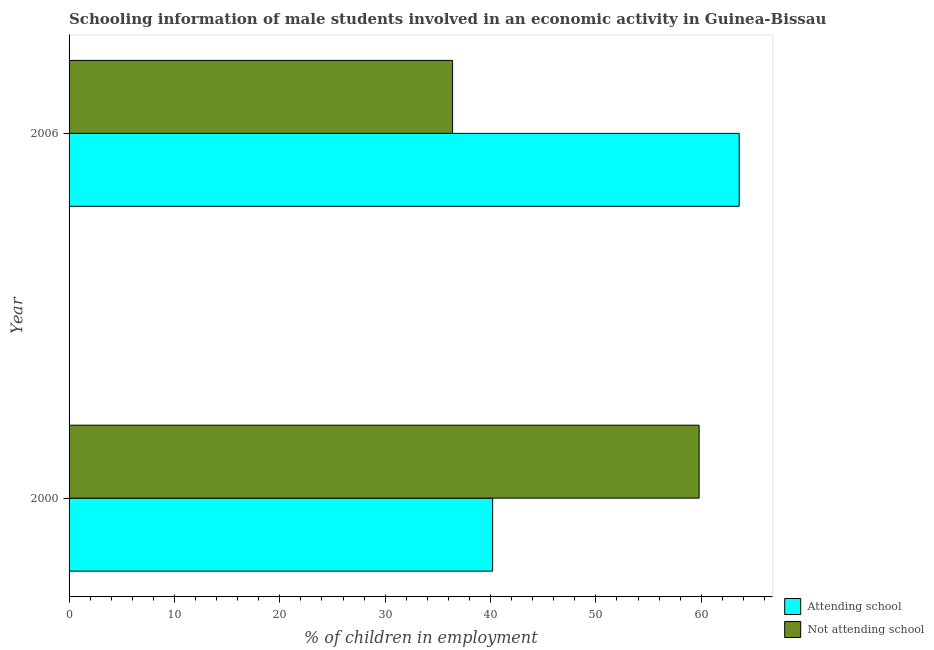How many different coloured bars are there?
Keep it short and to the point. 2. Are the number of bars per tick equal to the number of legend labels?
Ensure brevity in your answer.  Yes. What is the label of the 2nd group of bars from the top?
Offer a very short reply. 2000. What is the percentage of employed males who are not attending school in 2000?
Your response must be concise. 59.8. Across all years, what is the maximum percentage of employed males who are attending school?
Ensure brevity in your answer.  63.6. Across all years, what is the minimum percentage of employed males who are not attending school?
Keep it short and to the point. 36.4. In which year was the percentage of employed males who are not attending school maximum?
Your response must be concise. 2000. What is the total percentage of employed males who are not attending school in the graph?
Keep it short and to the point. 96.2. What is the difference between the percentage of employed males who are attending school in 2000 and that in 2006?
Keep it short and to the point. -23.4. What is the difference between the percentage of employed males who are not attending school in 2000 and the percentage of employed males who are attending school in 2006?
Your answer should be compact. -3.8. What is the average percentage of employed males who are not attending school per year?
Make the answer very short. 48.1. In the year 2006, what is the difference between the percentage of employed males who are attending school and percentage of employed males who are not attending school?
Make the answer very short. 27.2. What is the ratio of the percentage of employed males who are not attending school in 2000 to that in 2006?
Offer a very short reply. 1.64. What does the 1st bar from the top in 2006 represents?
Your answer should be compact. Not attending school. What does the 2nd bar from the bottom in 2006 represents?
Provide a short and direct response. Not attending school. Are all the bars in the graph horizontal?
Offer a very short reply. Yes. What is the difference between two consecutive major ticks on the X-axis?
Offer a very short reply. 10. Are the values on the major ticks of X-axis written in scientific E-notation?
Make the answer very short. No. Does the graph contain grids?
Your answer should be very brief. No. Where does the legend appear in the graph?
Your answer should be very brief. Bottom right. What is the title of the graph?
Your answer should be compact. Schooling information of male students involved in an economic activity in Guinea-Bissau. What is the label or title of the X-axis?
Offer a very short reply. % of children in employment. What is the % of children in employment of Attending school in 2000?
Make the answer very short. 40.2. What is the % of children in employment of Not attending school in 2000?
Provide a succinct answer. 59.8. What is the % of children in employment of Attending school in 2006?
Provide a succinct answer. 63.6. What is the % of children in employment of Not attending school in 2006?
Offer a very short reply. 36.4. Across all years, what is the maximum % of children in employment in Attending school?
Your response must be concise. 63.6. Across all years, what is the maximum % of children in employment of Not attending school?
Ensure brevity in your answer.  59.8. Across all years, what is the minimum % of children in employment in Attending school?
Your answer should be compact. 40.2. Across all years, what is the minimum % of children in employment in Not attending school?
Provide a short and direct response. 36.4. What is the total % of children in employment of Attending school in the graph?
Ensure brevity in your answer.  103.8. What is the total % of children in employment of Not attending school in the graph?
Your answer should be very brief. 96.2. What is the difference between the % of children in employment in Attending school in 2000 and that in 2006?
Offer a terse response. -23.4. What is the difference between the % of children in employment in Not attending school in 2000 and that in 2006?
Provide a short and direct response. 23.4. What is the difference between the % of children in employment in Attending school in 2000 and the % of children in employment in Not attending school in 2006?
Offer a very short reply. 3.8. What is the average % of children in employment of Attending school per year?
Give a very brief answer. 51.9. What is the average % of children in employment of Not attending school per year?
Make the answer very short. 48.1. In the year 2000, what is the difference between the % of children in employment of Attending school and % of children in employment of Not attending school?
Keep it short and to the point. -19.6. In the year 2006, what is the difference between the % of children in employment of Attending school and % of children in employment of Not attending school?
Provide a short and direct response. 27.2. What is the ratio of the % of children in employment of Attending school in 2000 to that in 2006?
Your response must be concise. 0.63. What is the ratio of the % of children in employment in Not attending school in 2000 to that in 2006?
Make the answer very short. 1.64. What is the difference between the highest and the second highest % of children in employment of Attending school?
Your answer should be compact. 23.4. What is the difference between the highest and the second highest % of children in employment of Not attending school?
Provide a succinct answer. 23.4. What is the difference between the highest and the lowest % of children in employment in Attending school?
Offer a terse response. 23.4. What is the difference between the highest and the lowest % of children in employment of Not attending school?
Give a very brief answer. 23.4. 